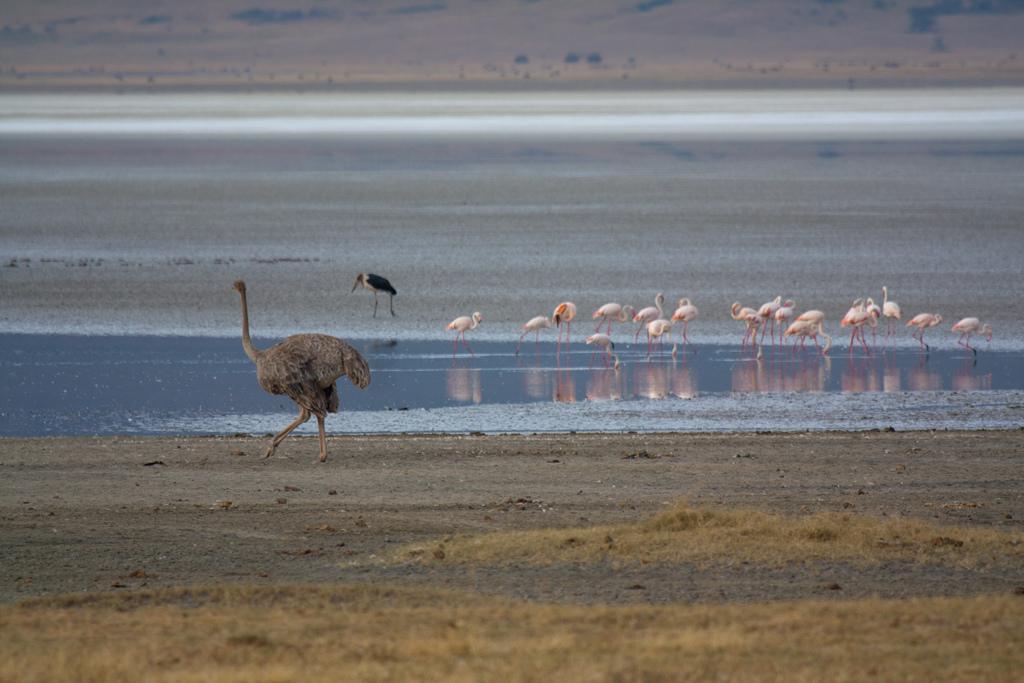Could you give a brief overview of what you see in this image? The picture is clicked near a water body. In the center of the picture there are flamingos, crane, ostrich, soil and water. The background is blurred. 